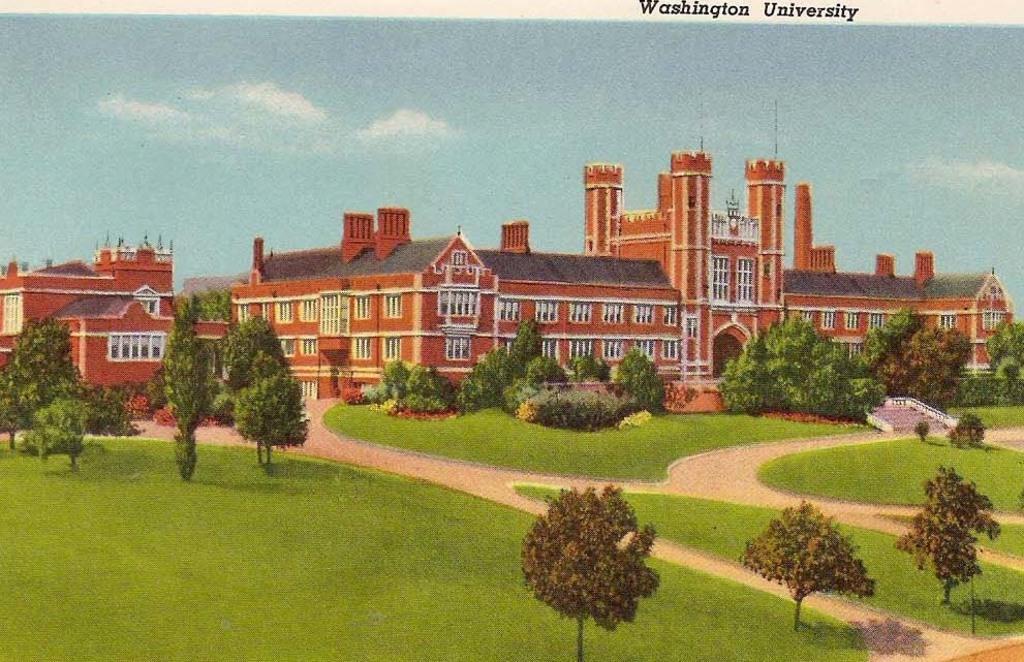Please provide a concise description of this image. In this picture we can observe some trees. There is grass on the ground. We can observe a building which is in red color. In the background there is a sky. 